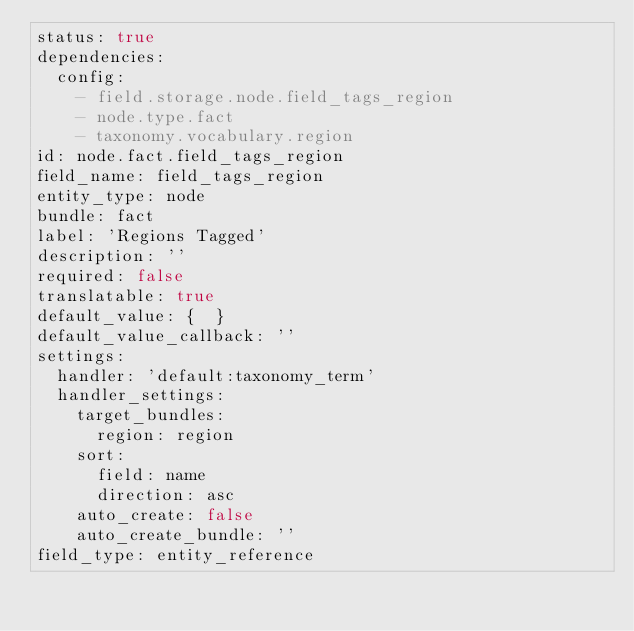Convert code to text. <code><loc_0><loc_0><loc_500><loc_500><_YAML_>status: true
dependencies:
  config:
    - field.storage.node.field_tags_region
    - node.type.fact
    - taxonomy.vocabulary.region
id: node.fact.field_tags_region
field_name: field_tags_region
entity_type: node
bundle: fact
label: 'Regions Tagged'
description: ''
required: false
translatable: true
default_value: {  }
default_value_callback: ''
settings:
  handler: 'default:taxonomy_term'
  handler_settings:
    target_bundles:
      region: region
    sort:
      field: name
      direction: asc
    auto_create: false
    auto_create_bundle: ''
field_type: entity_reference
</code> 